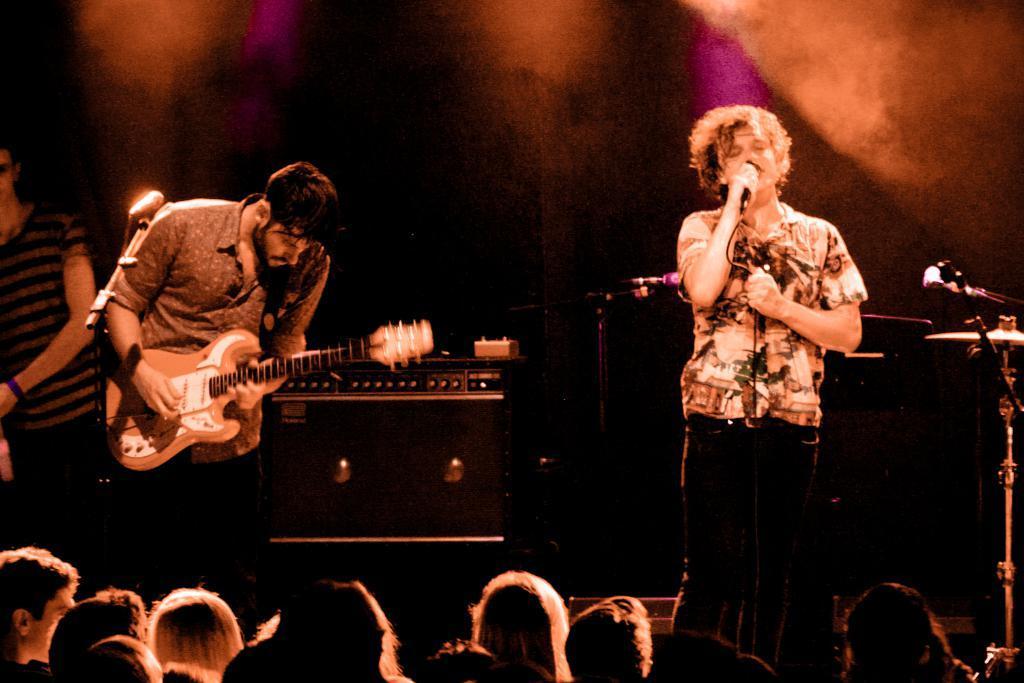Please provide a concise description of this image. In this picture there is the man who is playing guitar and another person who is singing 